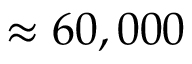<formula> <loc_0><loc_0><loc_500><loc_500>\approx 6 0 , 0 0 0</formula> 